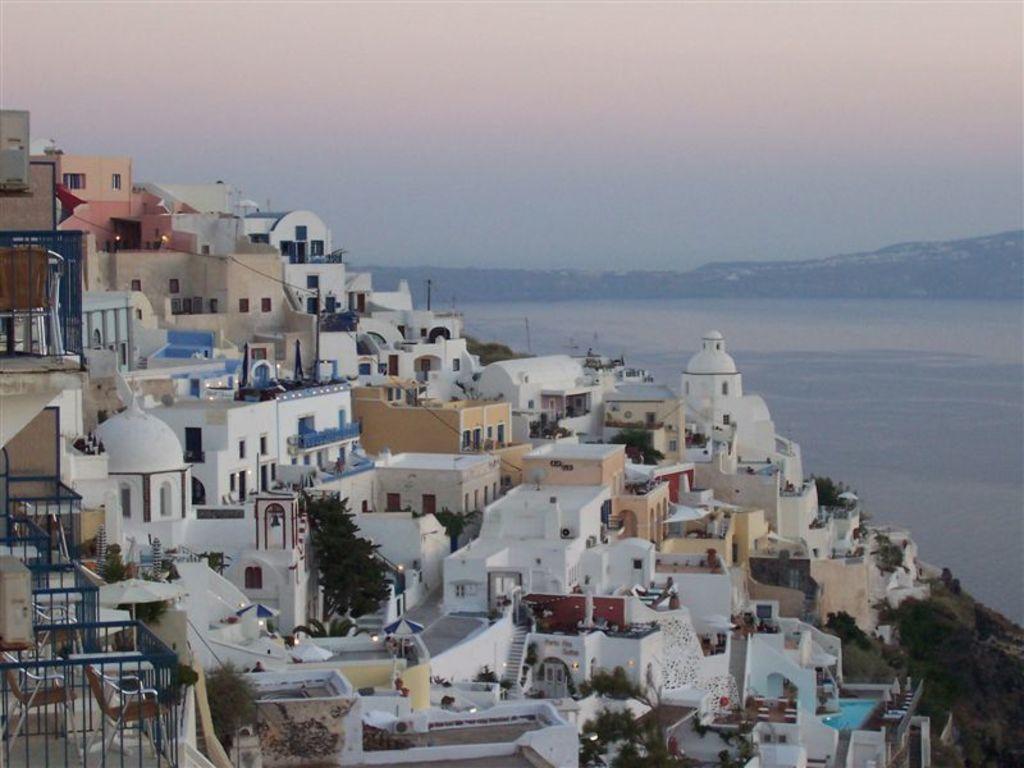In one or two sentences, can you explain what this image depicts? As we can see in the image there are buildings, stairs, trees and plants. There is water and in the background there are trees. At the top there is sky. 